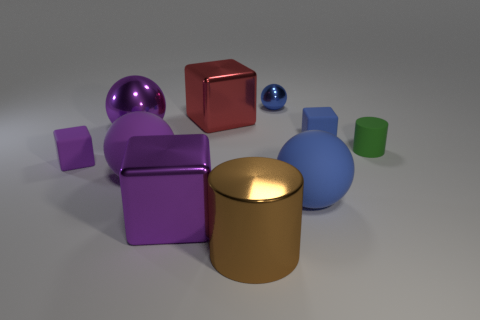There is a blue sphere that is the same material as the small green thing; what size is it?
Offer a very short reply. Large. What color is the rubber object that is in front of the tiny blue cube and to the right of the large blue sphere?
Keep it short and to the point. Green. Is the shape of the big purple shiny thing that is to the right of the big purple rubber ball the same as the big rubber thing that is to the left of the brown metallic thing?
Your response must be concise. No. What is the material of the large object right of the brown object?
Provide a short and direct response. Rubber. There is another rubber ball that is the same color as the tiny sphere; what size is it?
Offer a terse response. Large. What number of things are small blue things that are in front of the red object or small cylinders?
Provide a succinct answer. 2. Are there an equal number of tiny blue metal balls in front of the blue metal sphere and rubber objects?
Provide a succinct answer. No. Is the size of the blue rubber ball the same as the red metallic object?
Offer a terse response. Yes. What is the color of the shiny sphere that is the same size as the purple rubber block?
Offer a terse response. Blue. Is the size of the green thing the same as the metallic object to the right of the large brown thing?
Offer a terse response. Yes. 